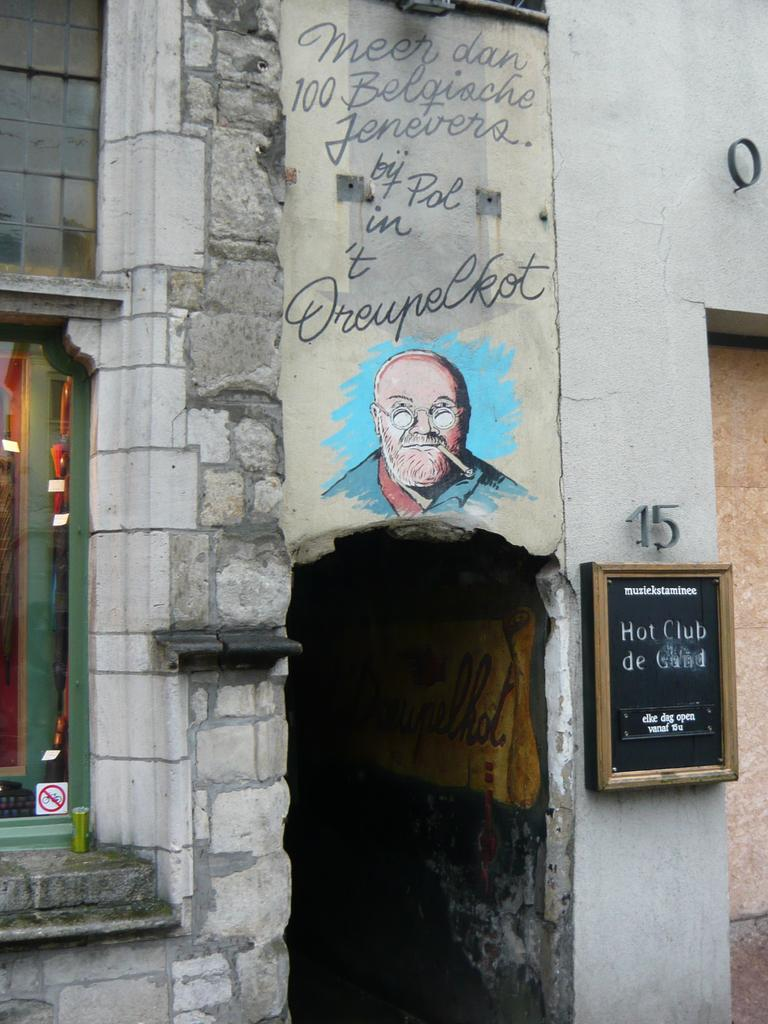What type of structure is visible in the image? There is a building in the image. What feature can be seen on the building? The building has a glass window. What is the board in the image used for? The purpose of the board in the image is not specified, but it could be used for displaying information or announcements. What can be found on the wall in the image? There is a painting of a man and words and numbers on the wall. Where is the sister of the man in the painting located in the image? There is no sister of the man in the painting mentioned or visible in the image. What type of body is present in the image? There are no bodies present in the image; it features a building, a board, objects, and a painting of a man on the wall. 